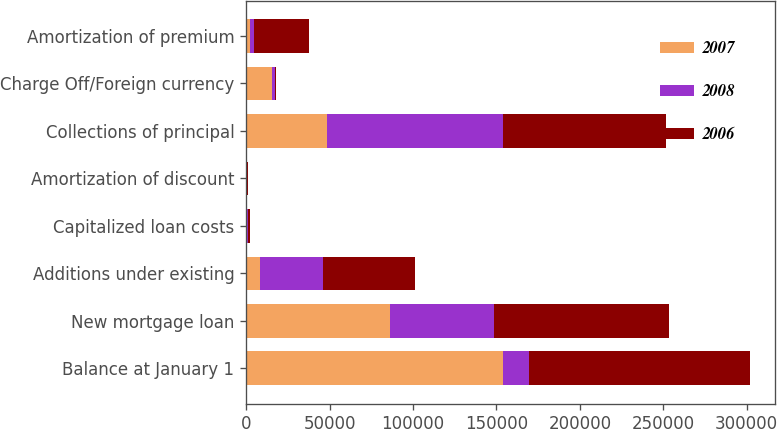Convert chart to OTSL. <chart><loc_0><loc_0><loc_500><loc_500><stacked_bar_chart><ecel><fcel>Balance at January 1<fcel>New mortgage loan<fcel>Additions under existing<fcel>Capitalized loan costs<fcel>Amortization of discount<fcel>Collections of principal<fcel>Charge Off/Foreign currency<fcel>Amortization of premium<nl><fcel>2007<fcel>153847<fcel>86247<fcel>8268<fcel>605<fcel>247<fcel>48633<fcel>15630<fcel>2279<nl><fcel>2008<fcel>15630<fcel>62362<fcel>38122<fcel>675<fcel>271<fcel>105277<fcel>1837<fcel>2298<nl><fcel>2006<fcel>132675<fcel>104892<fcel>54815<fcel>1305<fcel>673<fcel>97501<fcel>609<fcel>33003<nl></chart> 